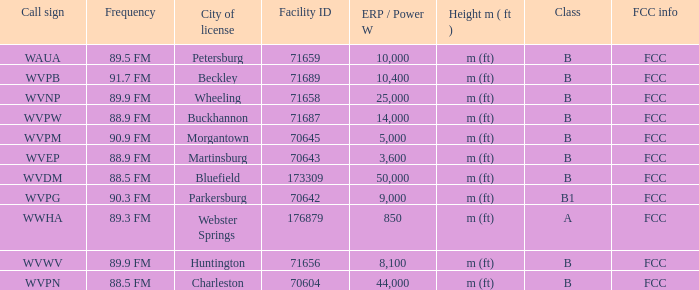What is the lowest facility ID that's in Beckley? 71689.0. 